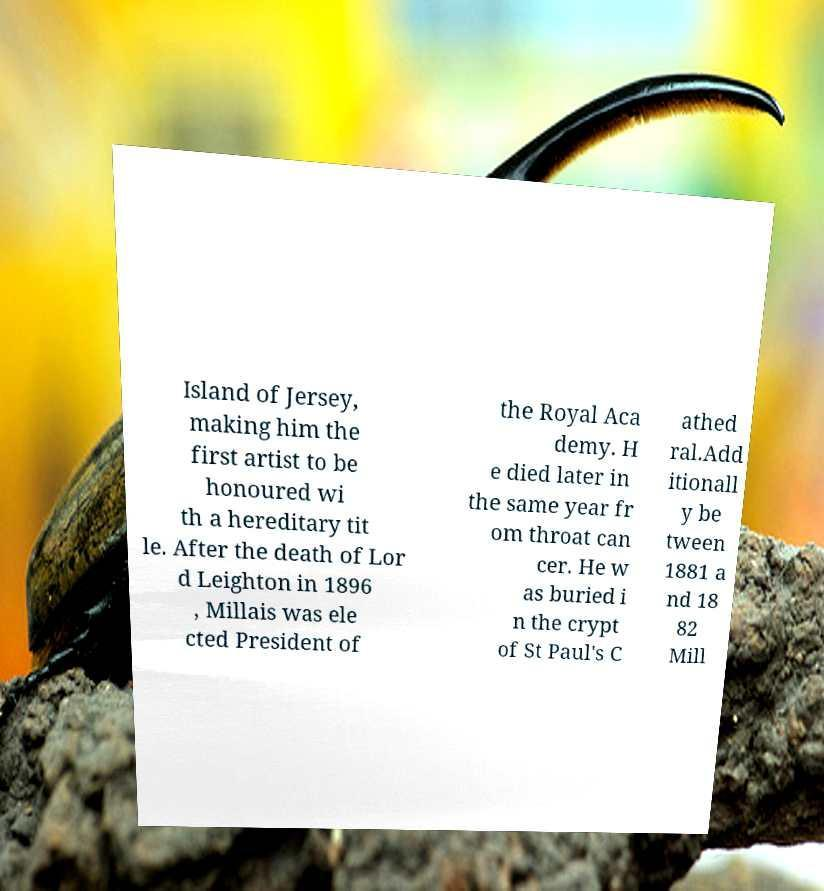Can you read and provide the text displayed in the image?This photo seems to have some interesting text. Can you extract and type it out for me? Island of Jersey, making him the first artist to be honoured wi th a hereditary tit le. After the death of Lor d Leighton in 1896 , Millais was ele cted President of the Royal Aca demy. H e died later in the same year fr om throat can cer. He w as buried i n the crypt of St Paul's C athed ral.Add itionall y be tween 1881 a nd 18 82 Mill 